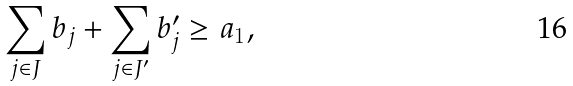<formula> <loc_0><loc_0><loc_500><loc_500>\sum _ { j \in J } b _ { j } + \sum _ { j \in J ^ { \prime } } b _ { j } ^ { \prime } \geq a _ { 1 } ,</formula> 